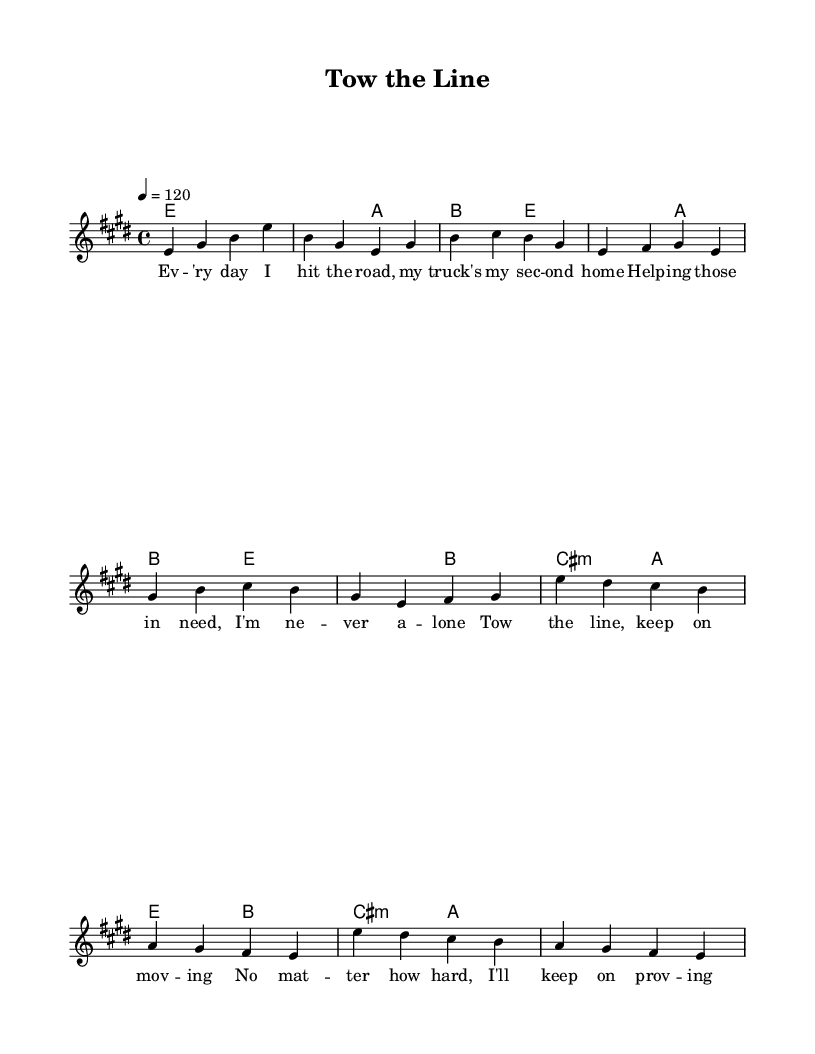What is the key signature of this music? The key signature is E major, which has four sharps: F#, C#, G#, and D#.
Answer: E major What is the time signature of this piece? The time signature is indicated as 4/4, which means there are four beats per measure and a quarter note gets one beat.
Answer: 4/4 What is the tempo marking for this music? The tempo marking is 120 beats per minute, as indicated in the score, which defines the speed of the piece.
Answer: 120 How many measures are in the verse section? The verse section consists of 4 measures, as seen in the melody line when counting the bars; each group of notes separated by vertical lines indicates a measure.
Answer: 4 What type of cadence ends the chorus section? The chorus ends with an imperfect cadence, as it does not resolve to the tonic and leaves the section feeling incomplete or unfinished.
Answer: Imperfect Which musical form does this piece most closely resemble? This piece resembles verse-chorus form, where the structure alternates between verses and a repeated chorus, typical in classic rock song formats.
Answer: Verse-chorus What genre does this song best fit? This song fits the classic rock genre, noted for its themes of hard work and perseverance, often represented in its lyrics and melodic style.
Answer: Classic rock 